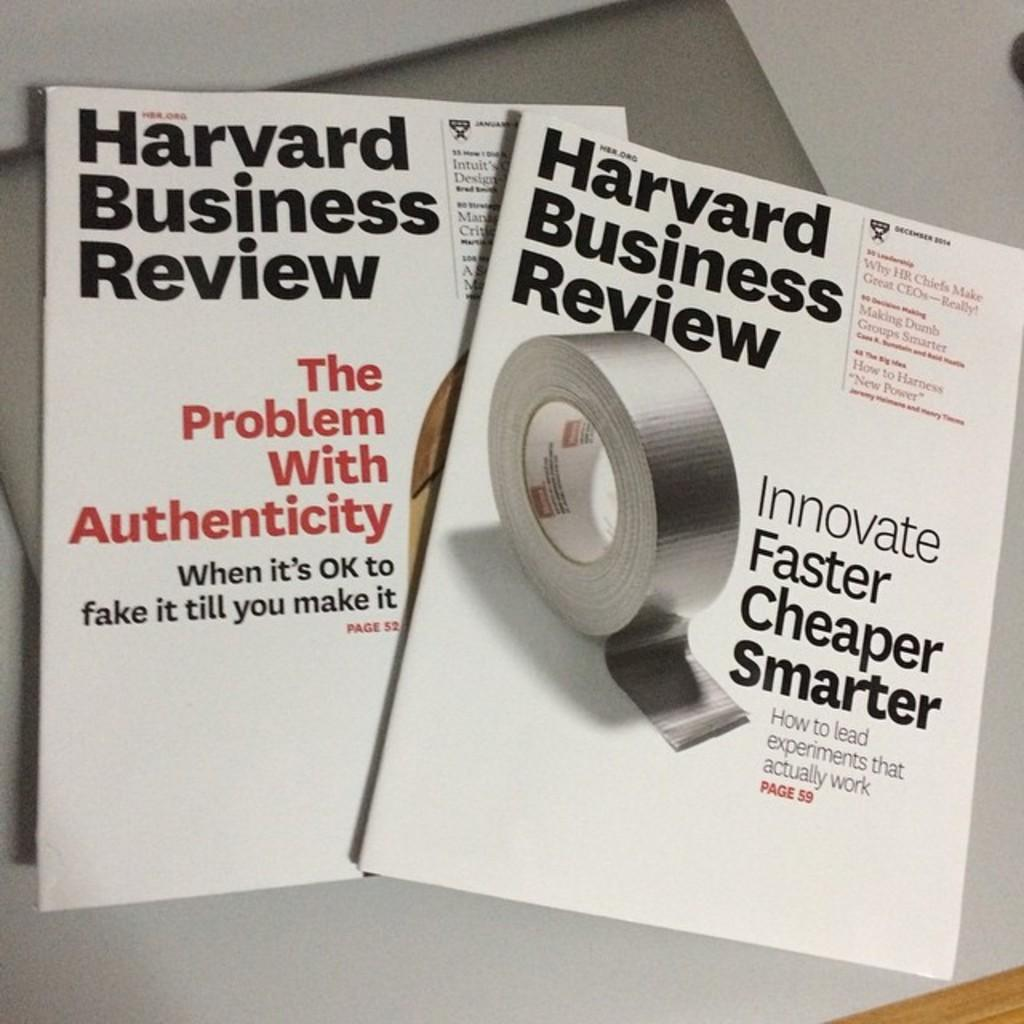<image>
Relay a brief, clear account of the picture shown. The Harvard Business Review has some great articles to read. 